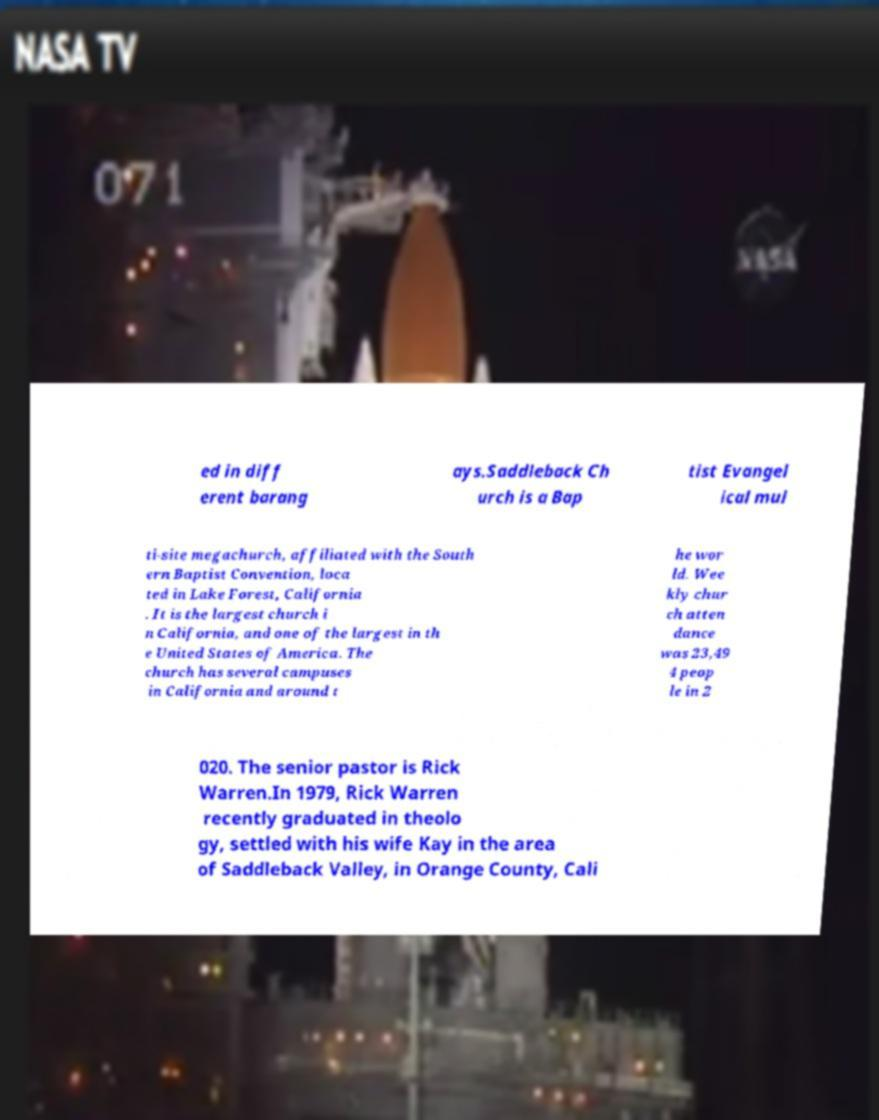For documentation purposes, I need the text within this image transcribed. Could you provide that? ed in diff erent barang ays.Saddleback Ch urch is a Bap tist Evangel ical mul ti-site megachurch, affiliated with the South ern Baptist Convention, loca ted in Lake Forest, California . It is the largest church i n California, and one of the largest in th e United States of America. The church has several campuses in California and around t he wor ld. Wee kly chur ch atten dance was 23,49 4 peop le in 2 020. The senior pastor is Rick Warren.In 1979, Rick Warren recently graduated in theolo gy, settled with his wife Kay in the area of Saddleback Valley, in Orange County, Cali 